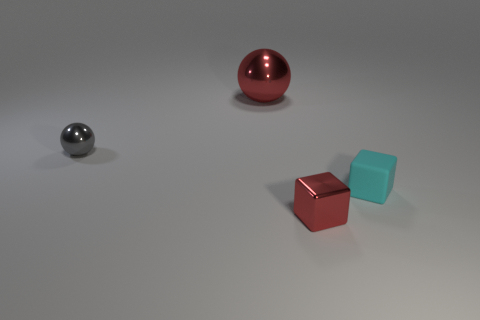The large red object is what shape?
Your answer should be compact. Sphere. What is the size of the other object that is the same shape as the large shiny object?
Keep it short and to the point. Small. Is there anything else that is the same material as the small cyan block?
Your answer should be compact. No. What material is the red object behind the tiny rubber block?
Give a very brief answer. Metal. How many other objects are there of the same color as the matte block?
Your answer should be very brief. 0. What is the large thing made of?
Make the answer very short. Metal. The tiny object that is both to the left of the small cyan rubber cube and in front of the gray ball is made of what material?
Provide a succinct answer. Metal. What number of things are both behind the gray metallic thing and in front of the tiny gray thing?
Make the answer very short. 0. How many shiny objects are right of the big red object?
Your answer should be compact. 1. Is there another green object that has the same shape as the matte object?
Ensure brevity in your answer.  No. 